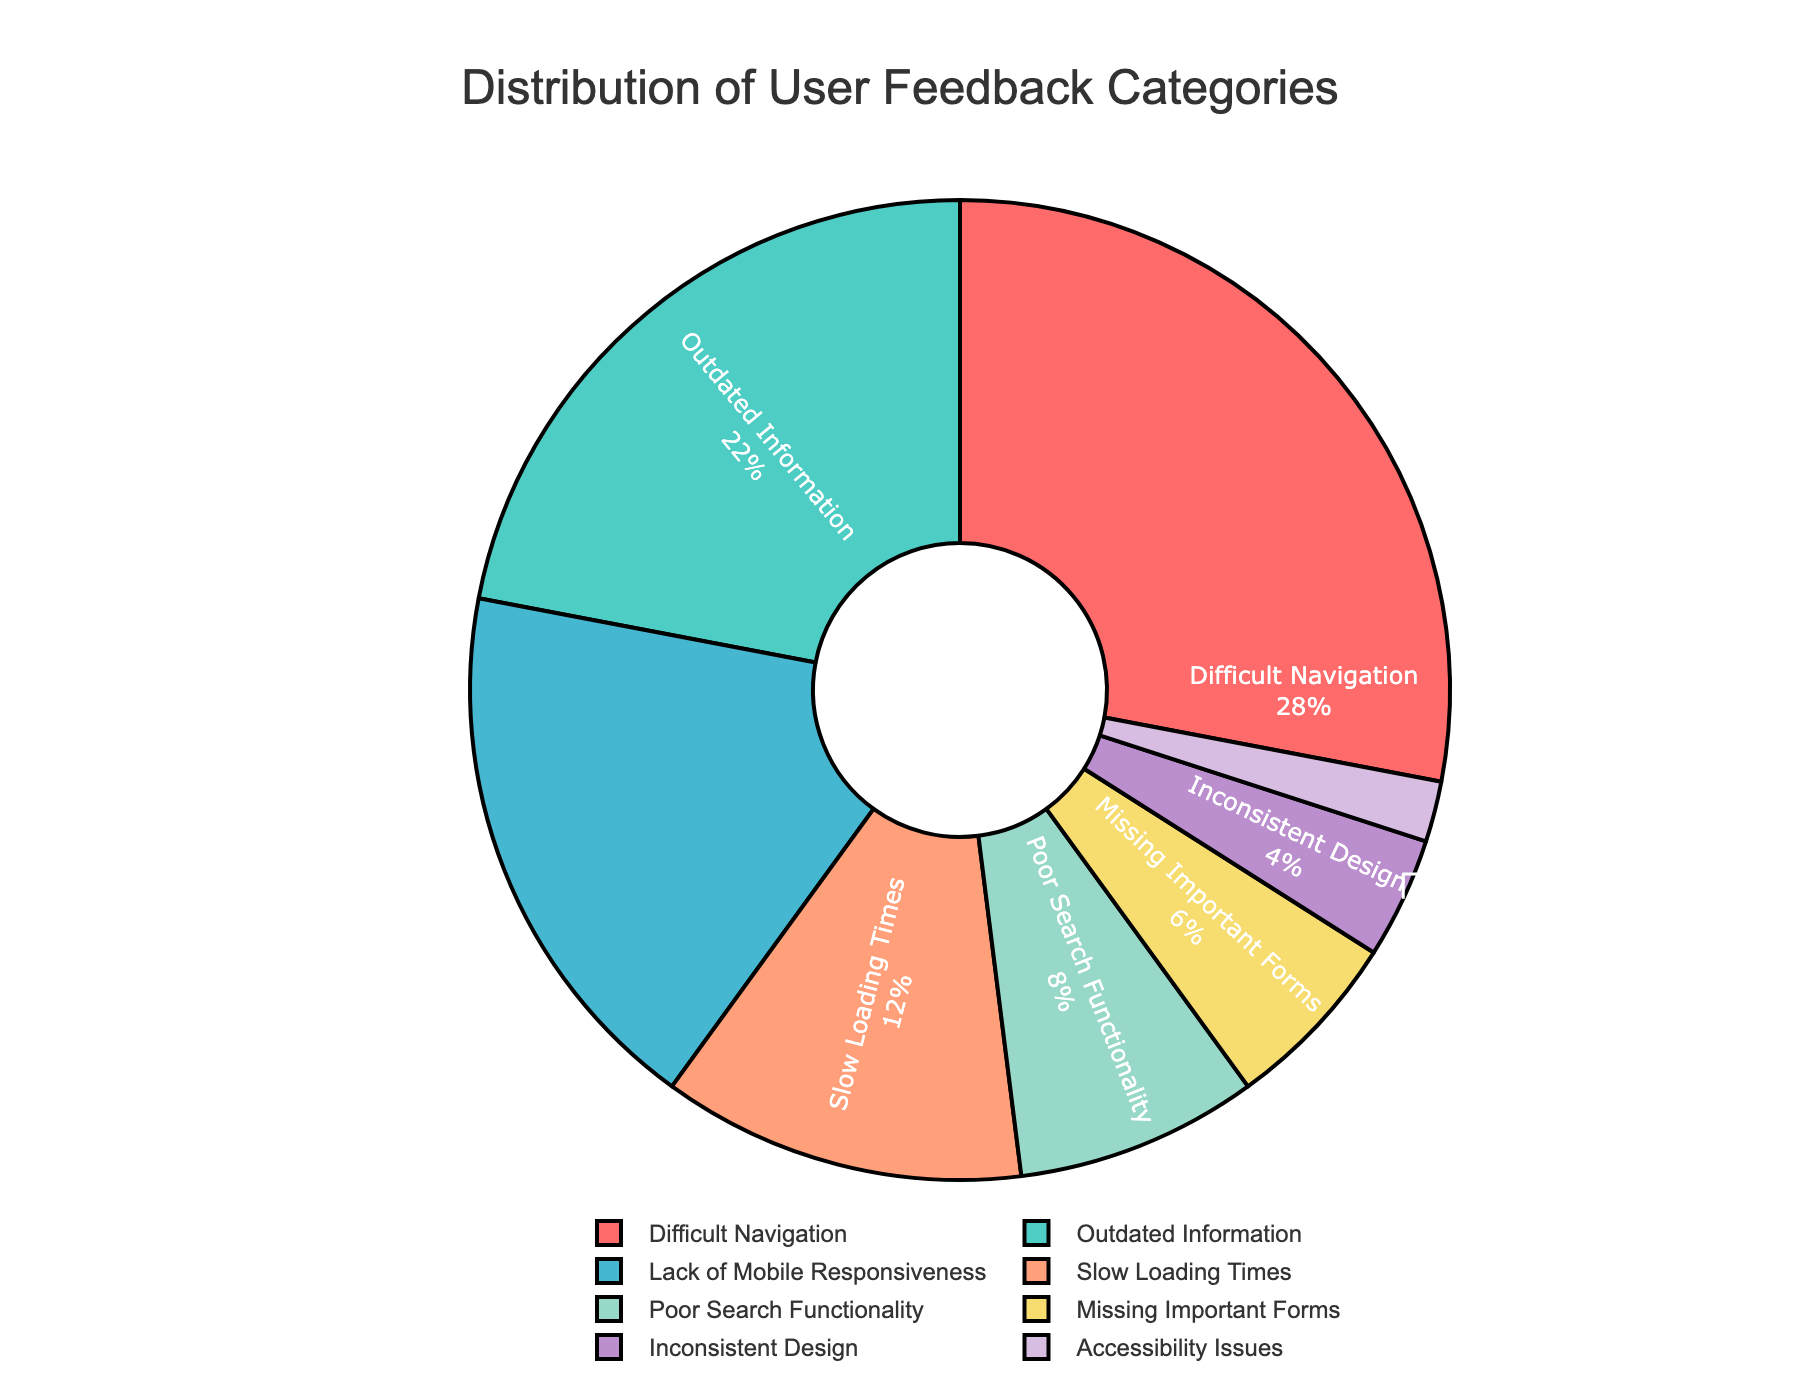What percentage of feedback mentions 'Outdated Information'? Locate the 'Outdated Information' category in the pie chart and read the percentage associated with it. The chart shows this category comprises 22%.
Answer: 22% What are the two most common categories of user feedback? Look for the largest two sections in the pie chart. The two largest sections correspond to 'Difficult Navigation' and 'Outdated Information', which have the highest percentages.
Answer: Difficult Navigation and Outdated Information How much more feedback is there about 'Difficult Navigation' compared to 'Slow Loading Times'? Identify the percentages for both categories: 'Difficult Navigation' is 28% and 'Slow Loading Times' is 12%. Subtract 12% from 28% to get the difference: 28% - 12% = 16%.
Answer: 16% Which category has the least user feedback? The smallest section in the pie chart represents the category with the least feedback. This category is 'Accessibility Issues' with 2%.
Answer: Accessibility Issues What is the combined percentage of feedback related to 'Poor Search Functionality' and 'Missing Important Forms'? Locate each category and determine their percentages: 'Poor Search Functionality' is 8% and 'Missing Important Forms' is 6%. Add these two percentages: 8% + 6% = 14%.
Answer: 14% Which category is highlighted in green? Identify the section of the pie chart that is colored green. The 'Outdated Information' category is highlighted in green.
Answer: Outdated Information Is there a larger percentage of feedback about 'Lack of Mobile Responsiveness' compared to 'Poor Search Functionality'? Compare the percentages of the two categories: 'Lack of Mobile Responsiveness' is 18% and 'Poor Search Functionality' is 8%. Since 18% > 8%, 'Lack of Mobile Responsiveness' has a larger percentage.
Answer: Yes What is the total percentage of feedback that concerns navigation and design issues ('Difficult Navigation' and 'Inconsistent Design')? Identify the percentages of both categories: 'Difficult Navigation' is 28% and 'Inconsistent Design' is 4%. Add these two percentages: 28% + 4% = 32%.
Answer: 32% 